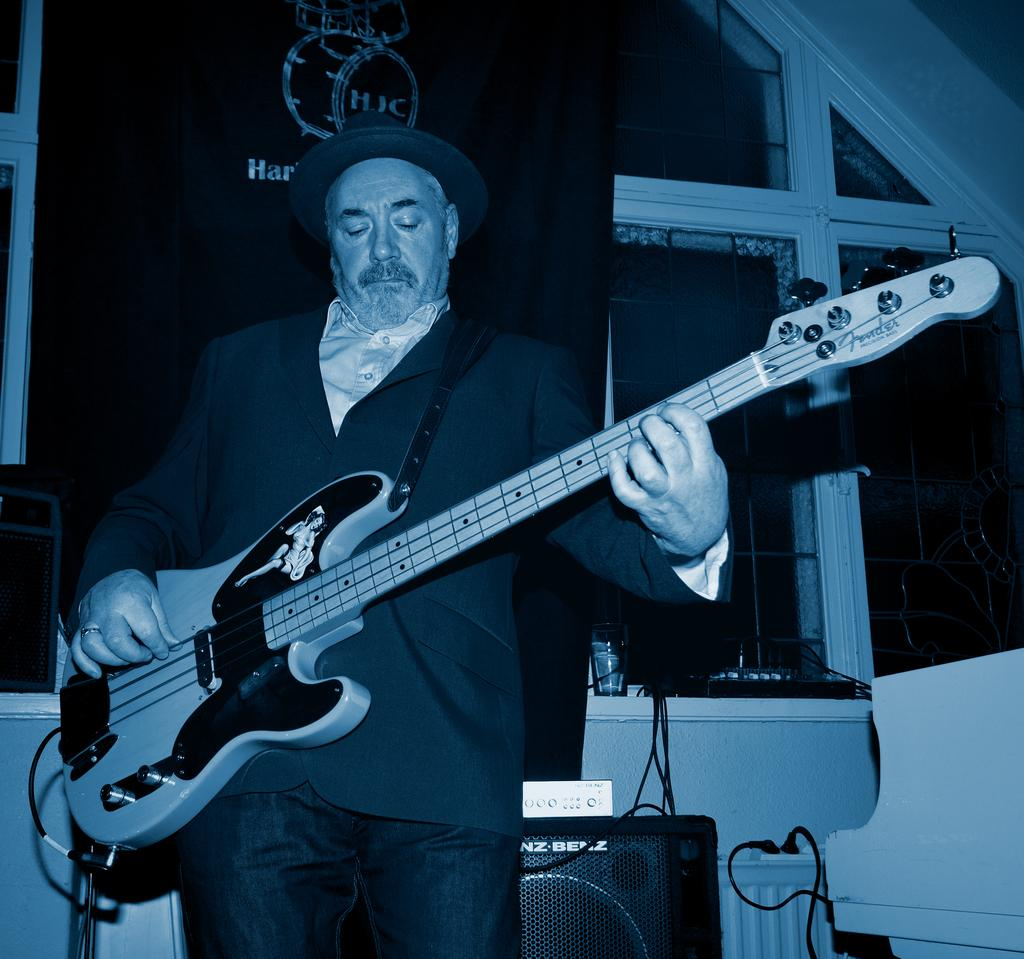What is the main subject of the image? There is a man in the image. What is the man doing in the image? The man is playing a guitar. What type of dinosaurs can be seen playing the guitar in the image? There are no dinosaurs present in the image, and therefore no dinosaurs playing the guitar. 